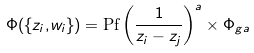Convert formula to latex. <formula><loc_0><loc_0><loc_500><loc_500>\Phi ( \{ z _ { i } , & w _ { i } \} ) = \text {Pf} \left ( \frac { 1 } { z _ { i } - z _ { j } } \right ) ^ { a } \times \Phi _ { g a }</formula> 